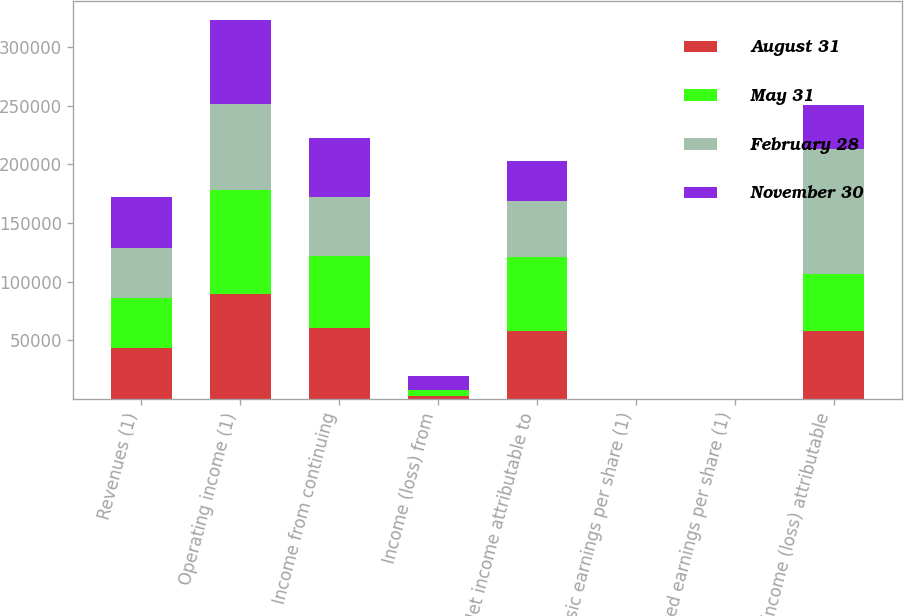Convert chart. <chart><loc_0><loc_0><loc_500><loc_500><stacked_bar_chart><ecel><fcel>Revenues (1)<fcel>Operating income (1)<fcel>Income from continuing<fcel>Income (loss) from<fcel>Net income attributable to<fcel>Basic earnings per share (1)<fcel>Diluted earnings per share (1)<fcel>Net income (loss) attributable<nl><fcel>August 31<fcel>43010<fcel>89243<fcel>60256<fcel>2188<fcel>57831<fcel>0.72<fcel>0.71<fcel>57527<nl><fcel>May 31<fcel>43010<fcel>88702<fcel>61314<fcel>4868<fcel>62835<fcel>0.77<fcel>0.76<fcel>48907<nl><fcel>February 28<fcel>43010<fcel>73849<fcel>50729<fcel>722<fcel>48461<fcel>0.6<fcel>0.59<fcel>106776<nl><fcel>November 30<fcel>43010<fcel>71485<fcel>50711<fcel>11679<fcel>34190<fcel>0.42<fcel>0.42<fcel>37559<nl></chart> 